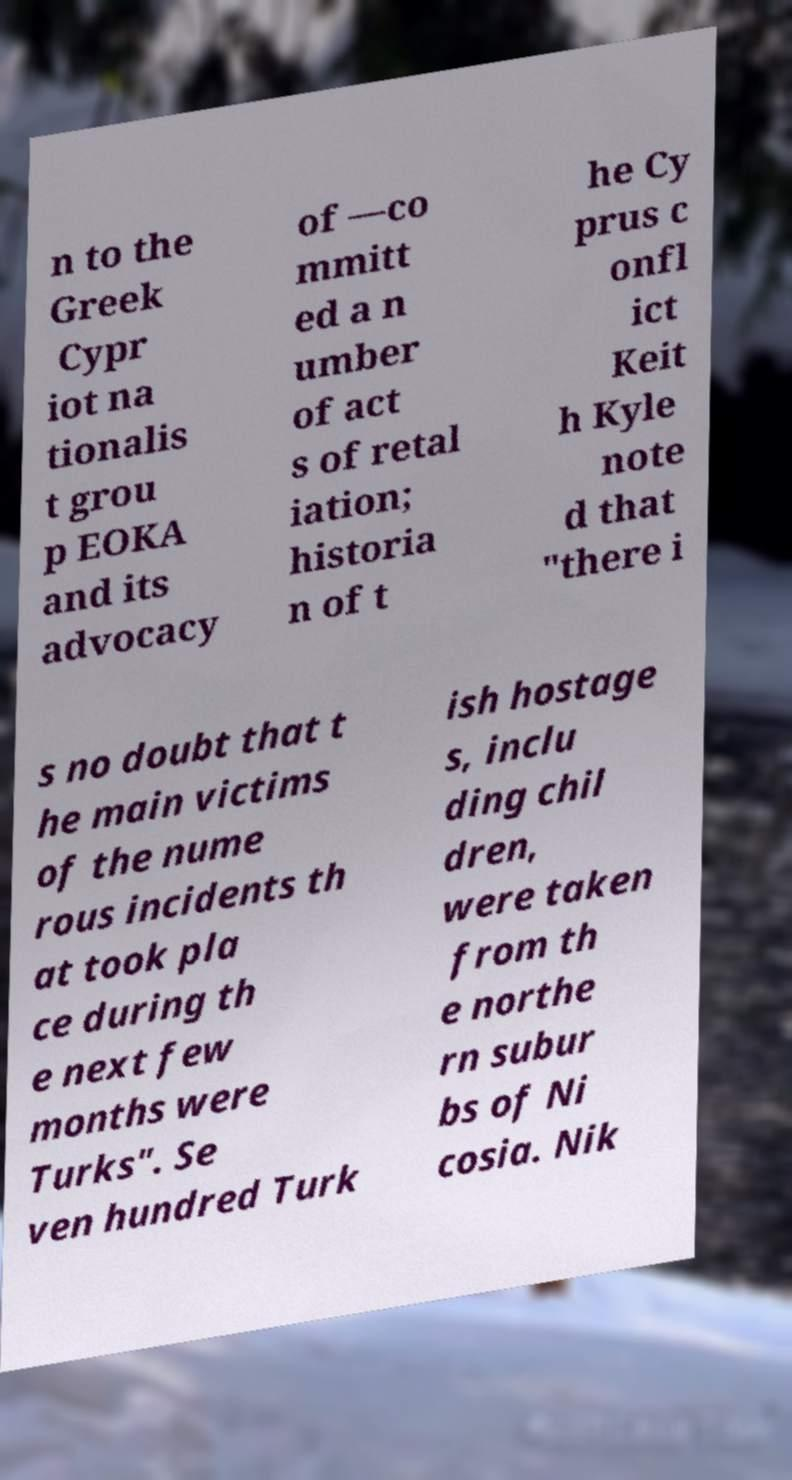Please identify and transcribe the text found in this image. n to the Greek Cypr iot na tionalis t grou p EOKA and its advocacy of —co mmitt ed a n umber of act s of retal iation; historia n of t he Cy prus c onfl ict Keit h Kyle note d that "there i s no doubt that t he main victims of the nume rous incidents th at took pla ce during th e next few months were Turks". Se ven hundred Turk ish hostage s, inclu ding chil dren, were taken from th e northe rn subur bs of Ni cosia. Nik 